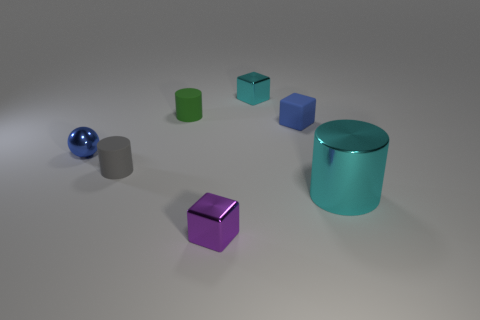Are the gray thing and the cyan cube made of the same material?
Provide a succinct answer. No. There is a tiny shiny thing that is on the left side of the cube that is in front of the shiny cylinder; how many cyan objects are in front of it?
Offer a terse response. 1. How many small shiny blocks are there?
Your response must be concise. 2. Is the number of small blue matte objects that are to the right of the blue block less than the number of shiny cylinders that are on the right side of the cyan shiny cylinder?
Ensure brevity in your answer.  No. Are there fewer metal objects in front of the tiny blue sphere than small purple cylinders?
Your response must be concise. No. What is the material of the small cube in front of the tiny rubber cylinder that is left of the tiny cylinder behind the blue sphere?
Keep it short and to the point. Metal. How many objects are small gray rubber cylinders that are behind the large cyan metal object or small cylinders that are in front of the green cylinder?
Keep it short and to the point. 1. What is the material of the purple object that is the same shape as the blue matte object?
Offer a terse response. Metal. What number of shiny objects are small blocks or tiny gray cylinders?
Provide a short and direct response. 2. There is a green object that is the same material as the blue block; what is its shape?
Provide a short and direct response. Cylinder. 